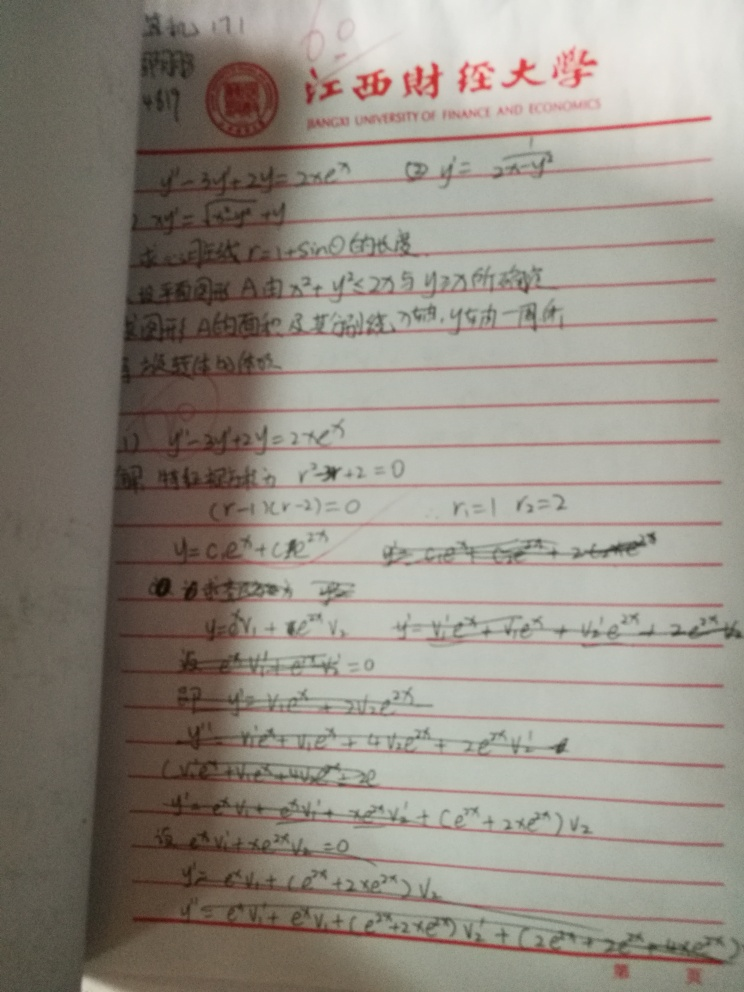Is the text in a language other than English, and if so, what can be inferred about the context in which it is used? Yes, the text is written in Chinese, suggesting its use in an educational context likely within a Chinese-speaking region. This can be inferred from the organized presentation typical of educational materials and possibly used in a classroom setting or for personal study. How do the mathematical formulas presented here compare to those typically taught in Western educational systems? The mathematical formulas and concepts are universally taught, however, the methodology and examples used might differ. Typically, Eastern educational systems, like in China, often focus more on rigorous practice and memorization, while Western systems might incorporate more application-based learning styles. 